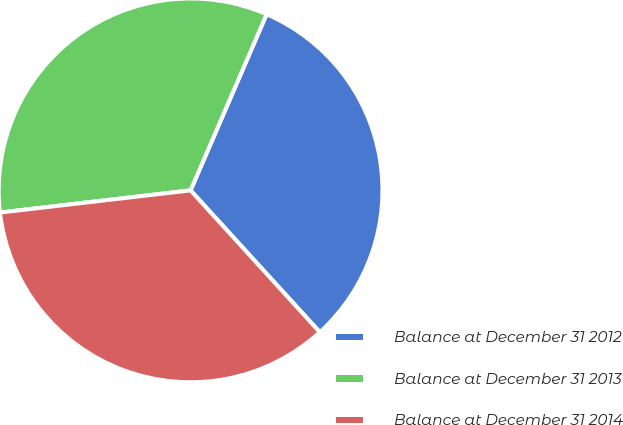Convert chart to OTSL. <chart><loc_0><loc_0><loc_500><loc_500><pie_chart><fcel>Balance at December 31 2012<fcel>Balance at December 31 2013<fcel>Balance at December 31 2014<nl><fcel>31.75%<fcel>33.33%<fcel>34.92%<nl></chart> 